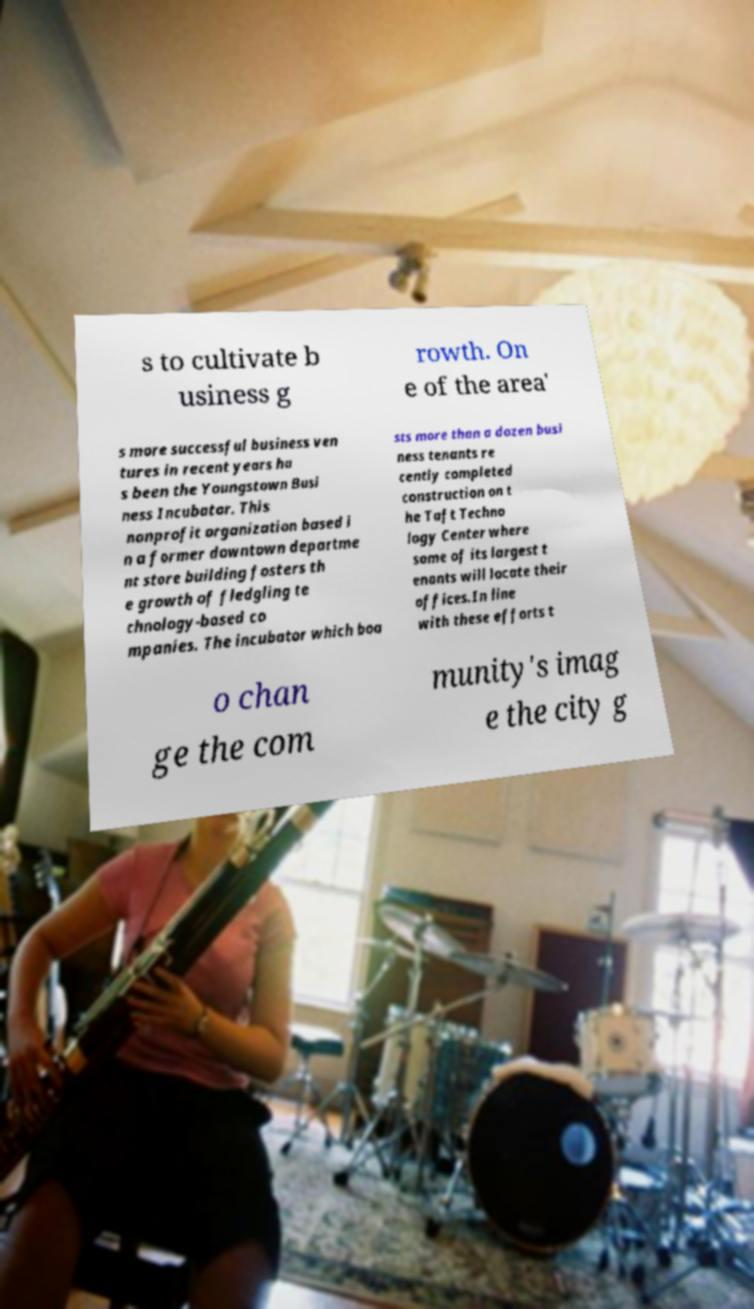Please identify and transcribe the text found in this image. s to cultivate b usiness g rowth. On e of the area' s more successful business ven tures in recent years ha s been the Youngstown Busi ness Incubator. This nonprofit organization based i n a former downtown departme nt store building fosters th e growth of fledgling te chnology-based co mpanies. The incubator which boa sts more than a dozen busi ness tenants re cently completed construction on t he Taft Techno logy Center where some of its largest t enants will locate their offices.In line with these efforts t o chan ge the com munity's imag e the city g 